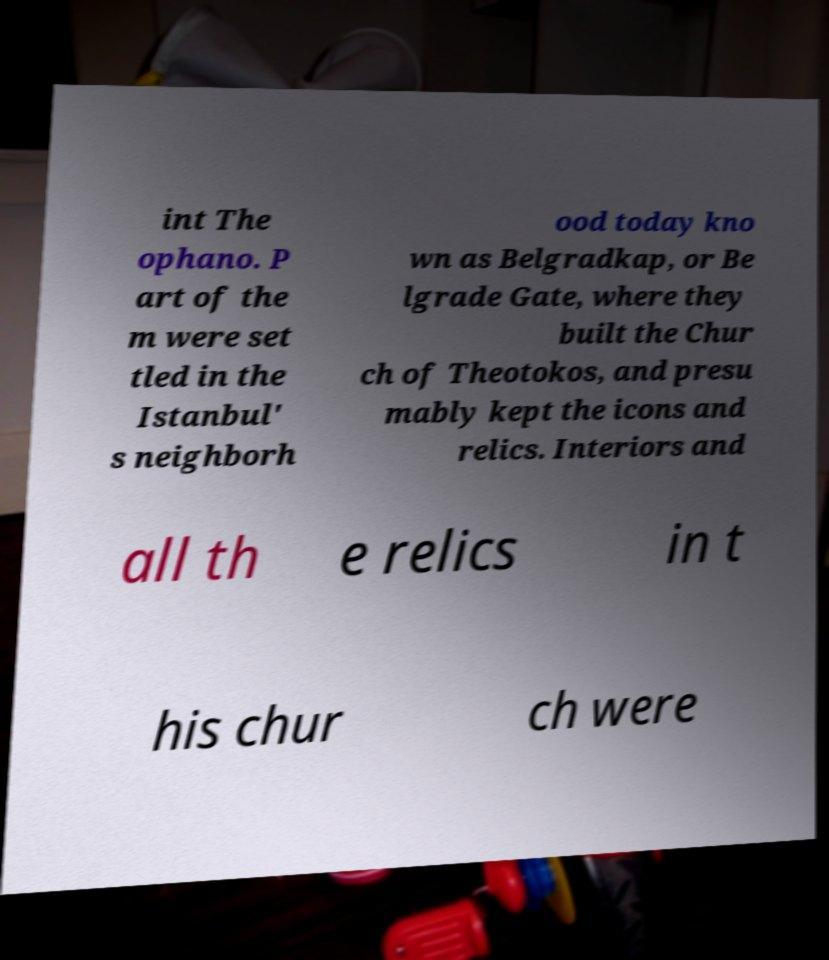Can you accurately transcribe the text from the provided image for me? int The ophano. P art of the m were set tled in the Istanbul' s neighborh ood today kno wn as Belgradkap, or Be lgrade Gate, where they built the Chur ch of Theotokos, and presu mably kept the icons and relics. Interiors and all th e relics in t his chur ch were 